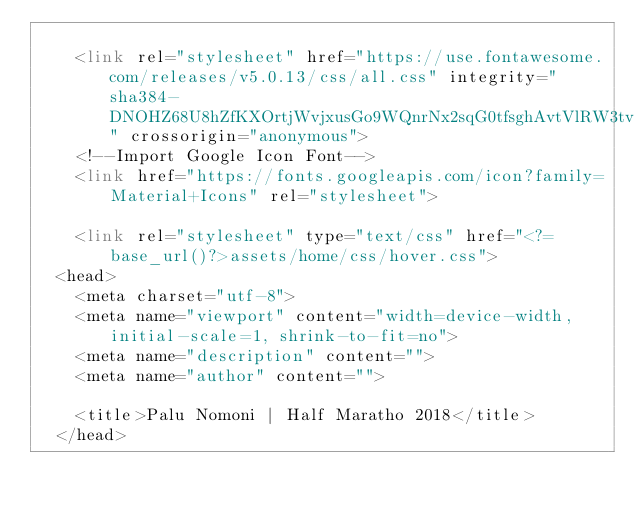Convert code to text. <code><loc_0><loc_0><loc_500><loc_500><_PHP_>
    <link rel="stylesheet" href="https://use.fontawesome.com/releases/v5.0.13/css/all.css" integrity="sha384-DNOHZ68U8hZfKXOrtjWvjxusGo9WQnrNx2sqG0tfsghAvtVlRW3tvkXWZh58N9jp" crossorigin="anonymous">
    <!--Import Google Icon Font-->
    <link href="https://fonts.googleapis.com/icon?family=Material+Icons" rel="stylesheet">

    <link rel="stylesheet" type="text/css" href="<?=base_url()?>assets/home/css/hover.css">
  <head>
    <meta charset="utf-8">
    <meta name="viewport" content="width=device-width, initial-scale=1, shrink-to-fit=no">
    <meta name="description" content="">
    <meta name="author" content="">

    <title>Palu Nomoni | Half Maratho 2018</title>
  </head></code> 